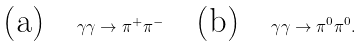Convert formula to latex. <formula><loc_0><loc_0><loc_500><loc_500>\text {(a)} \quad \gamma \gamma \to \pi ^ { + } \pi ^ { - } \quad \text {(b)} \quad \gamma \gamma \to \pi ^ { 0 } \pi ^ { 0 } .</formula> 